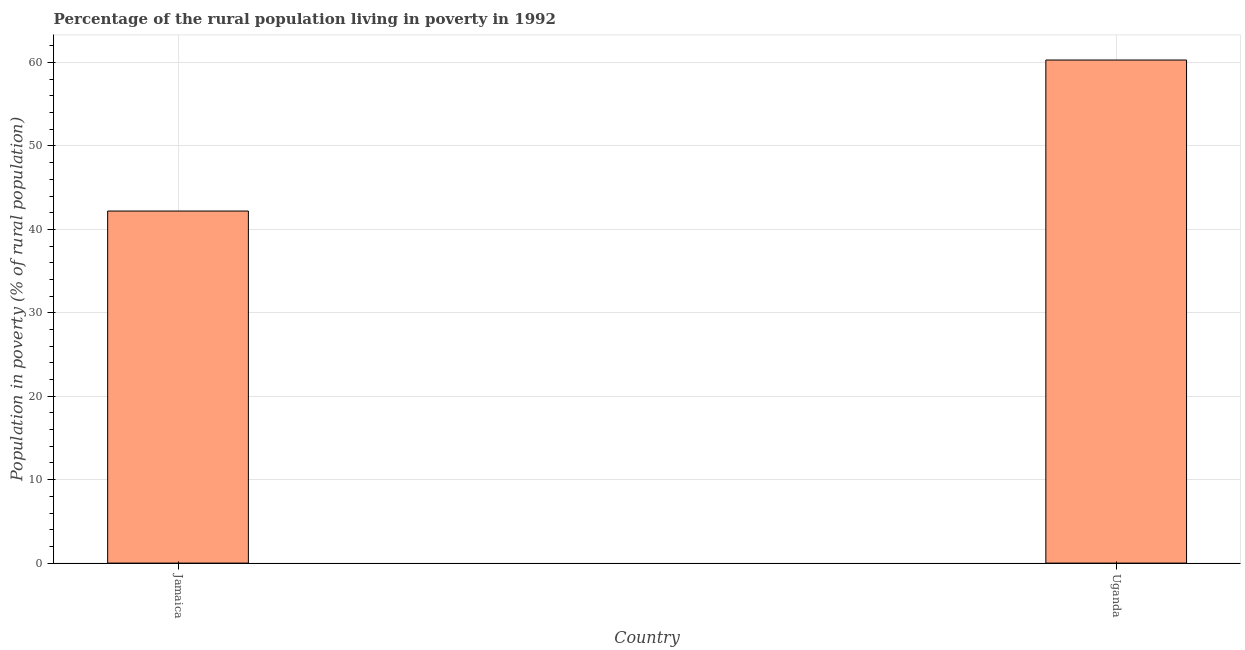Does the graph contain any zero values?
Offer a terse response. No. Does the graph contain grids?
Provide a short and direct response. Yes. What is the title of the graph?
Ensure brevity in your answer.  Percentage of the rural population living in poverty in 1992. What is the label or title of the Y-axis?
Offer a terse response. Population in poverty (% of rural population). What is the percentage of rural population living below poverty line in Jamaica?
Provide a short and direct response. 42.2. Across all countries, what is the maximum percentage of rural population living below poverty line?
Provide a succinct answer. 60.3. Across all countries, what is the minimum percentage of rural population living below poverty line?
Provide a succinct answer. 42.2. In which country was the percentage of rural population living below poverty line maximum?
Your answer should be compact. Uganda. In which country was the percentage of rural population living below poverty line minimum?
Make the answer very short. Jamaica. What is the sum of the percentage of rural population living below poverty line?
Make the answer very short. 102.5. What is the difference between the percentage of rural population living below poverty line in Jamaica and Uganda?
Give a very brief answer. -18.1. What is the average percentage of rural population living below poverty line per country?
Provide a short and direct response. 51.25. What is the median percentage of rural population living below poverty line?
Offer a very short reply. 51.25. In how many countries, is the percentage of rural population living below poverty line greater than the average percentage of rural population living below poverty line taken over all countries?
Provide a succinct answer. 1. How many bars are there?
Ensure brevity in your answer.  2. Are all the bars in the graph horizontal?
Your answer should be very brief. No. How many countries are there in the graph?
Give a very brief answer. 2. What is the difference between two consecutive major ticks on the Y-axis?
Provide a short and direct response. 10. What is the Population in poverty (% of rural population) in Jamaica?
Your answer should be very brief. 42.2. What is the Population in poverty (% of rural population) in Uganda?
Make the answer very short. 60.3. What is the difference between the Population in poverty (% of rural population) in Jamaica and Uganda?
Keep it short and to the point. -18.1. What is the ratio of the Population in poverty (% of rural population) in Jamaica to that in Uganda?
Provide a short and direct response. 0.7. 